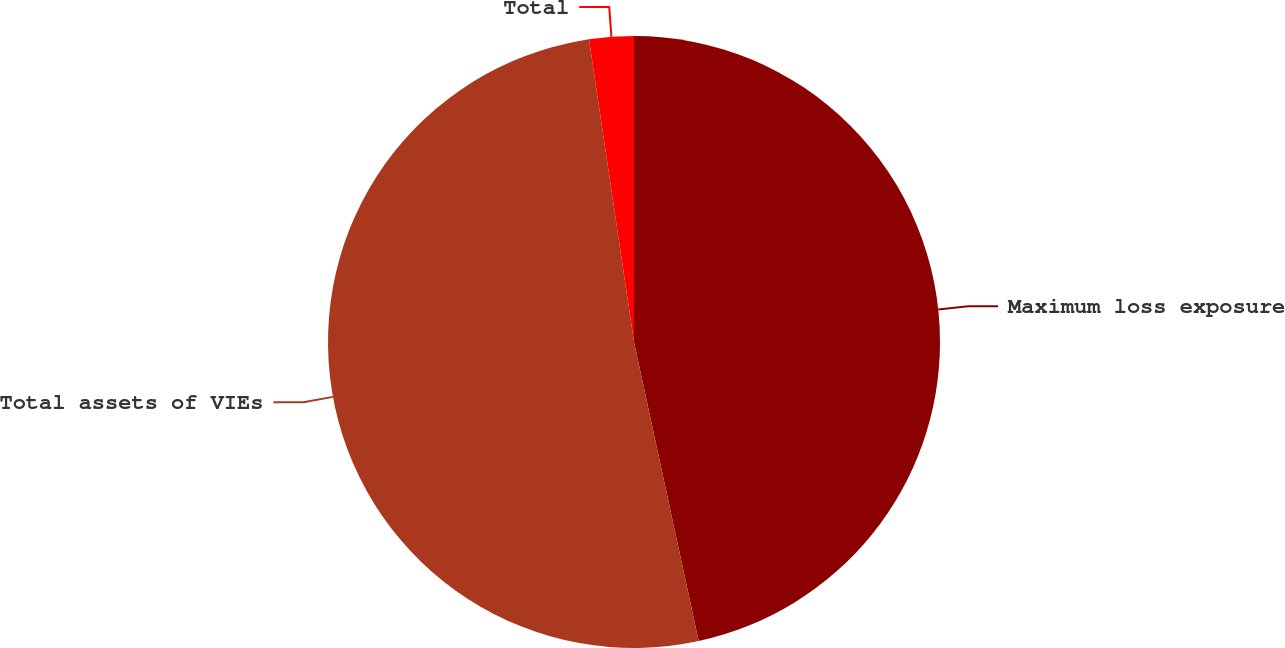Convert chart. <chart><loc_0><loc_0><loc_500><loc_500><pie_chart><fcel>Maximum loss exposure<fcel>Total assets of VIEs<fcel>Total<nl><fcel>46.61%<fcel>51.04%<fcel>2.35%<nl></chart> 